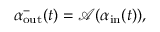<formula> <loc_0><loc_0><loc_500><loc_500>\alpha _ { o u t } ^ { - } ( t ) = \mathcal { A } ( \alpha _ { i n } ( t ) ) ,</formula> 